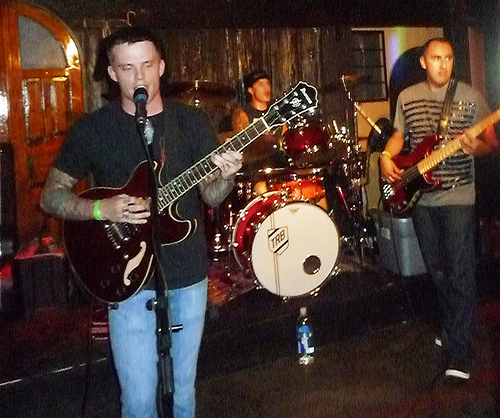<image>
Is the man behind the drum? No. The man is not behind the drum. From this viewpoint, the man appears to be positioned elsewhere in the scene. Is the musician in front of the mic? Yes. The musician is positioned in front of the mic, appearing closer to the camera viewpoint. 